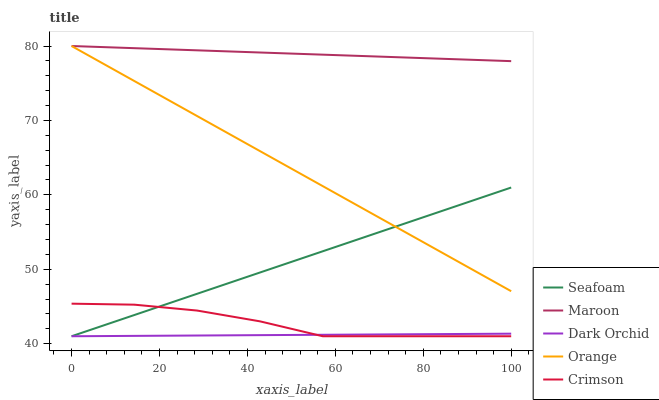Does Dark Orchid have the minimum area under the curve?
Answer yes or no. Yes. Does Maroon have the maximum area under the curve?
Answer yes or no. Yes. Does Orange have the minimum area under the curve?
Answer yes or no. No. Does Orange have the maximum area under the curve?
Answer yes or no. No. Is Dark Orchid the smoothest?
Answer yes or no. Yes. Is Crimson the roughest?
Answer yes or no. Yes. Is Orange the smoothest?
Answer yes or no. No. Is Orange the roughest?
Answer yes or no. No. Does Dark Orchid have the lowest value?
Answer yes or no. Yes. Does Orange have the lowest value?
Answer yes or no. No. Does Maroon have the highest value?
Answer yes or no. Yes. Does Crimson have the highest value?
Answer yes or no. No. Is Crimson less than Maroon?
Answer yes or no. Yes. Is Orange greater than Crimson?
Answer yes or no. Yes. Does Maroon intersect Orange?
Answer yes or no. Yes. Is Maroon less than Orange?
Answer yes or no. No. Is Maroon greater than Orange?
Answer yes or no. No. Does Crimson intersect Maroon?
Answer yes or no. No. 